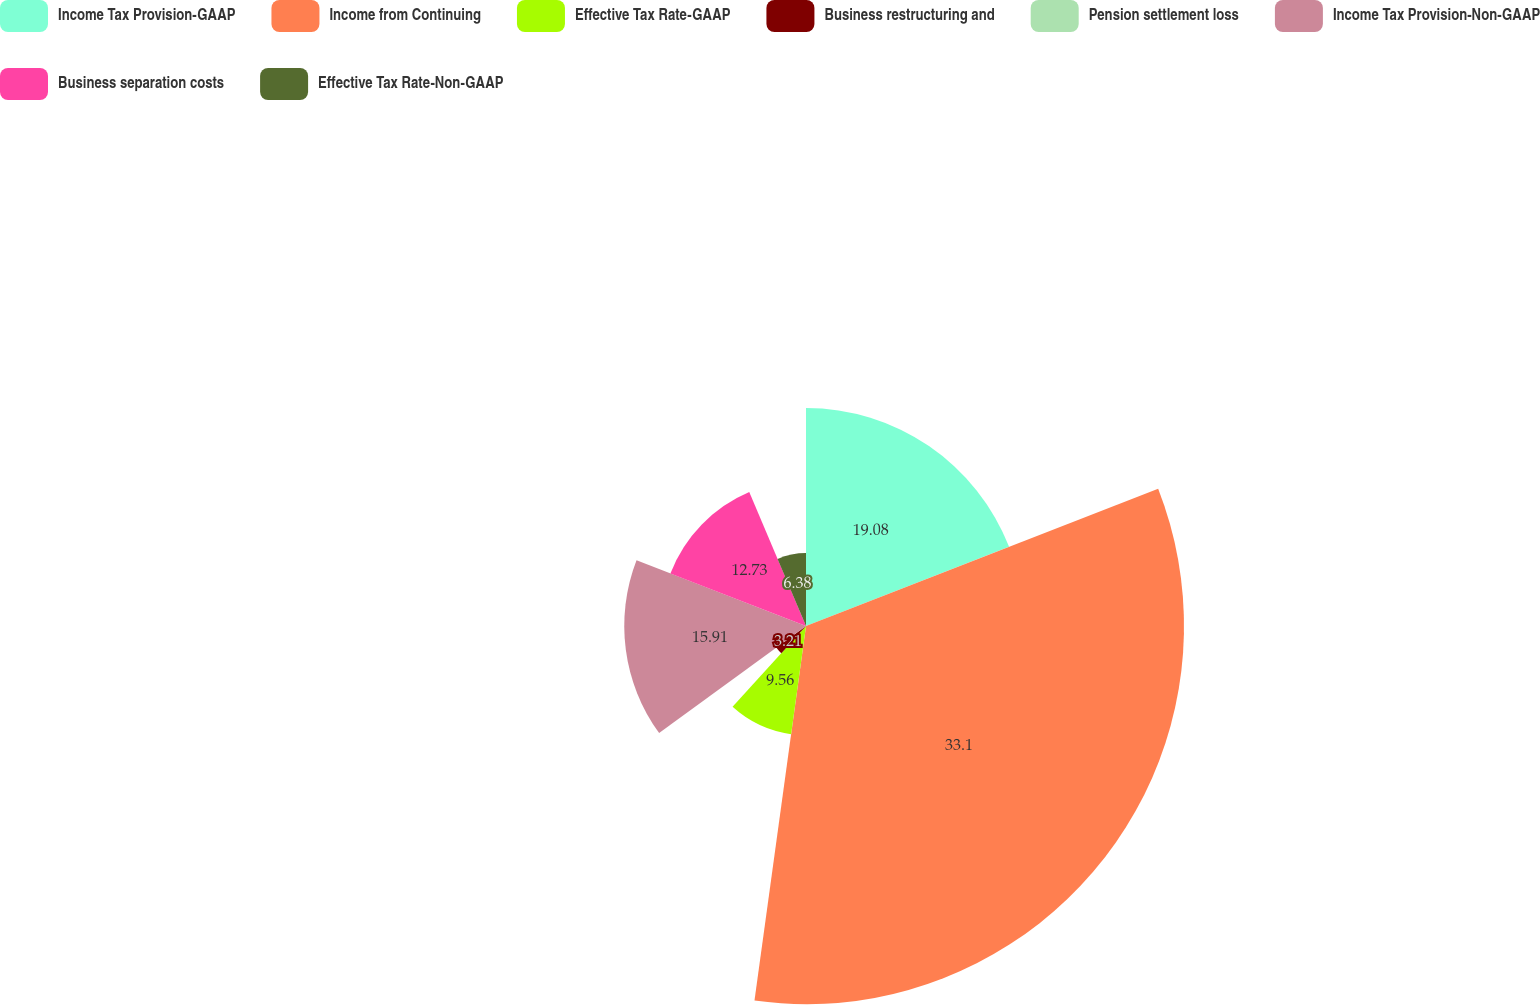Convert chart. <chart><loc_0><loc_0><loc_500><loc_500><pie_chart><fcel>Income Tax Provision-GAAP<fcel>Income from Continuing<fcel>Effective Tax Rate-GAAP<fcel>Business restructuring and<fcel>Pension settlement loss<fcel>Income Tax Provision-Non-GAAP<fcel>Business separation costs<fcel>Effective Tax Rate-Non-GAAP<nl><fcel>19.08%<fcel>33.09%<fcel>9.56%<fcel>3.21%<fcel>0.03%<fcel>15.91%<fcel>12.73%<fcel>6.38%<nl></chart> 